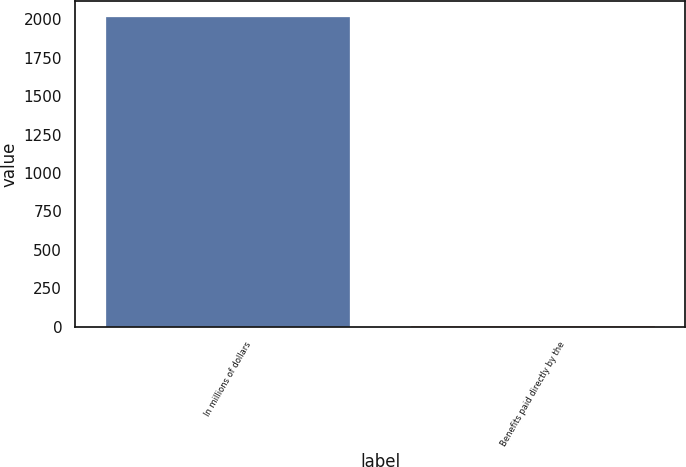Convert chart. <chart><loc_0><loc_0><loc_500><loc_500><bar_chart><fcel>In millions of dollars<fcel>Benefits paid directly by the<nl><fcel>2018<fcel>6<nl></chart> 